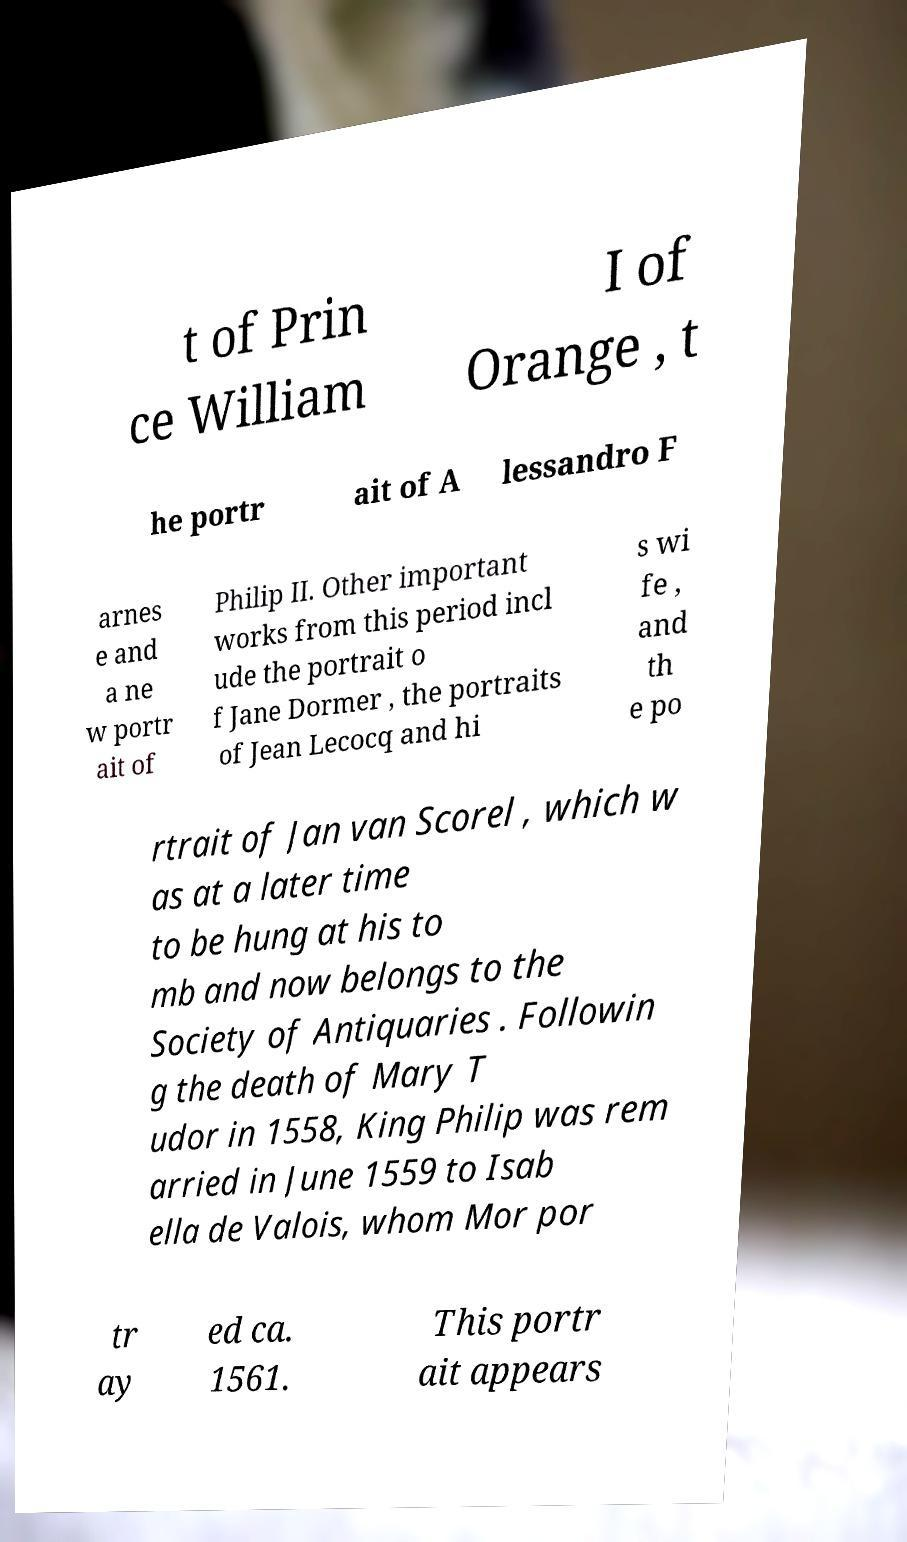Could you extract and type out the text from this image? t of Prin ce William I of Orange , t he portr ait of A lessandro F arnes e and a ne w portr ait of Philip II. Other important works from this period incl ude the portrait o f Jane Dormer , the portraits of Jean Lecocq and hi s wi fe , and th e po rtrait of Jan van Scorel , which w as at a later time to be hung at his to mb and now belongs to the Society of Antiquaries . Followin g the death of Mary T udor in 1558, King Philip was rem arried in June 1559 to Isab ella de Valois, whom Mor por tr ay ed ca. 1561. This portr ait appears 